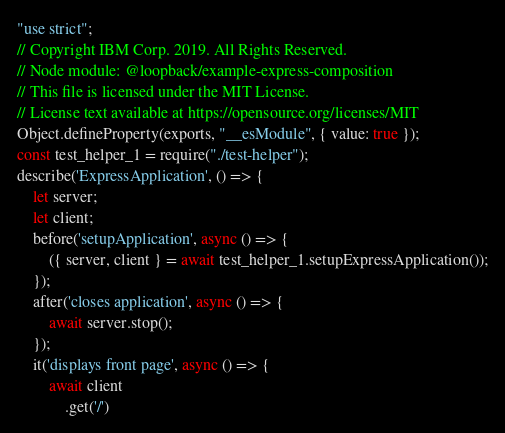<code> <loc_0><loc_0><loc_500><loc_500><_JavaScript_>"use strict";
// Copyright IBM Corp. 2019. All Rights Reserved.
// Node module: @loopback/example-express-composition
// This file is licensed under the MIT License.
// License text available at https://opensource.org/licenses/MIT
Object.defineProperty(exports, "__esModule", { value: true });
const test_helper_1 = require("./test-helper");
describe('ExpressApplication', () => {
    let server;
    let client;
    before('setupApplication', async () => {
        ({ server, client } = await test_helper_1.setupExpressApplication());
    });
    after('closes application', async () => {
        await server.stop();
    });
    it('displays front page', async () => {
        await client
            .get('/')</code> 